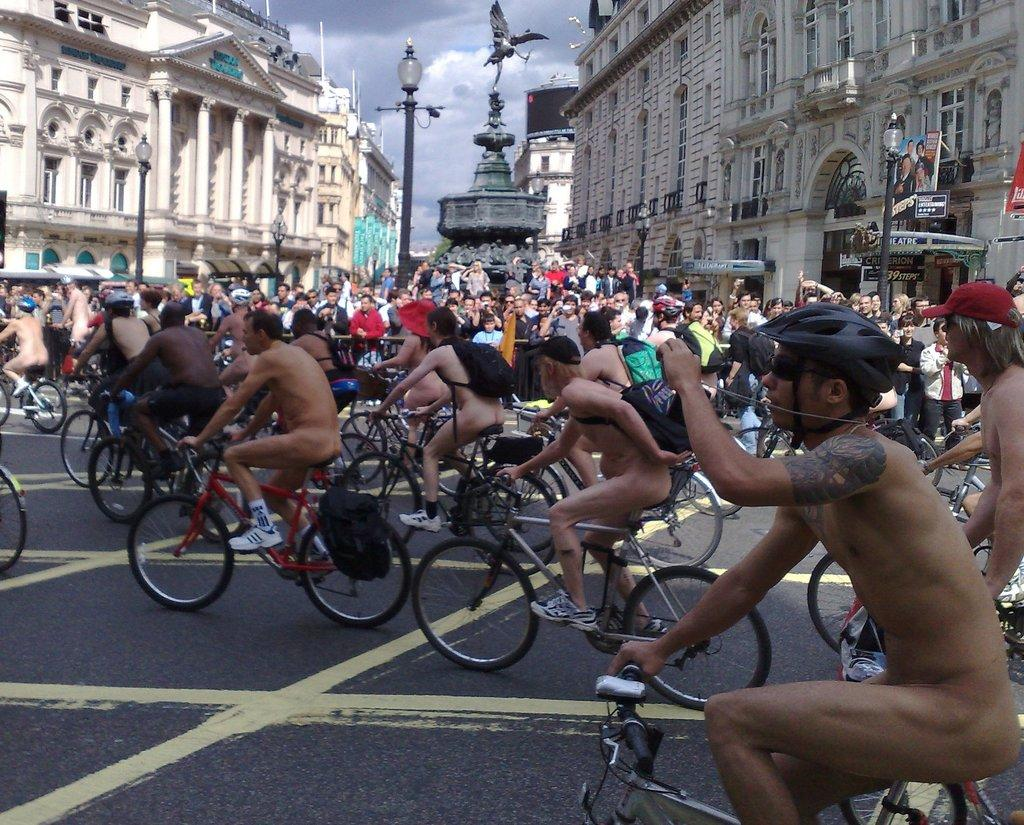How many people are in the image? There is a group of people in the image. What are the people doing in the image? The people are riding a bicycle. What can be seen in the background of the image? There is a building visible in the image. What type of channel can be seen in the image? There is no channel present in the image. What sound do the bells make in the image? There are no bells present in the image. 